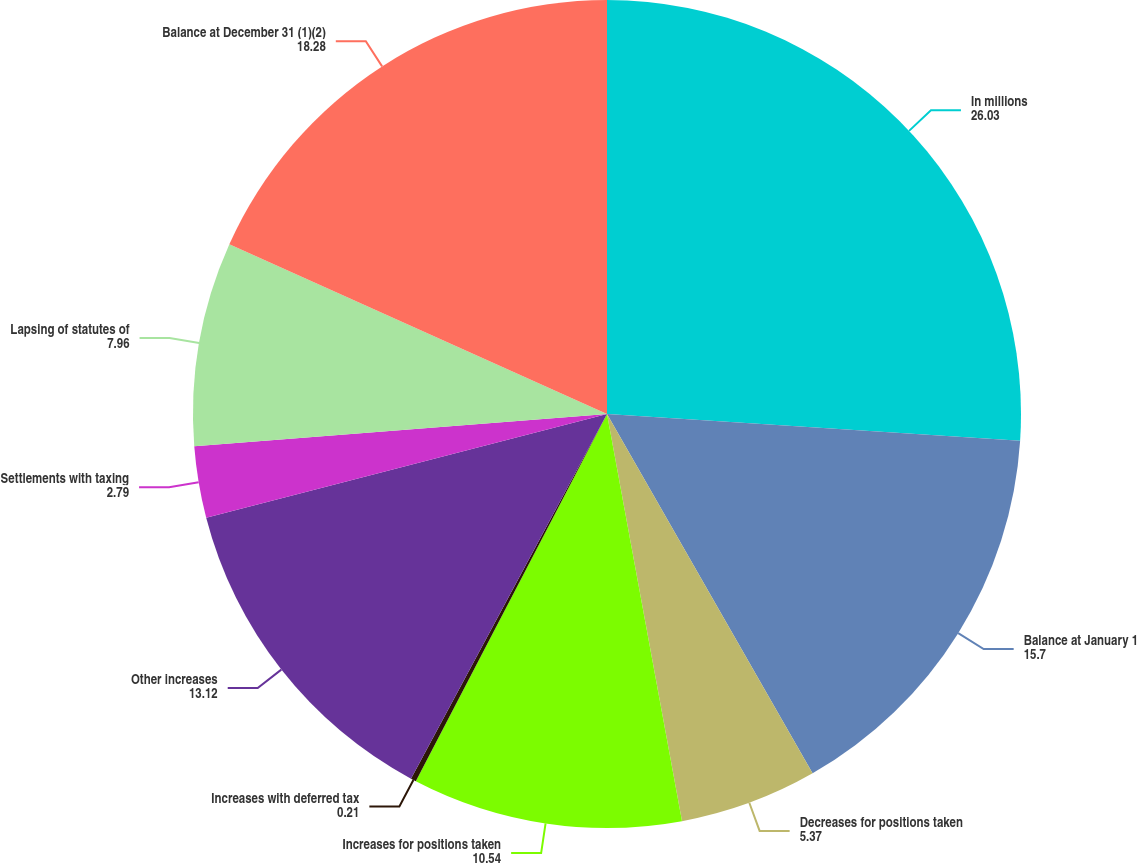<chart> <loc_0><loc_0><loc_500><loc_500><pie_chart><fcel>In millions<fcel>Balance at January 1<fcel>Decreases for positions taken<fcel>Increases for positions taken<fcel>Increases with deferred tax<fcel>Other increases<fcel>Settlements with taxing<fcel>Lapsing of statutes of<fcel>Balance at December 31 (1)(2)<nl><fcel>26.03%<fcel>15.7%<fcel>5.37%<fcel>10.54%<fcel>0.21%<fcel>13.12%<fcel>2.79%<fcel>7.96%<fcel>18.28%<nl></chart> 